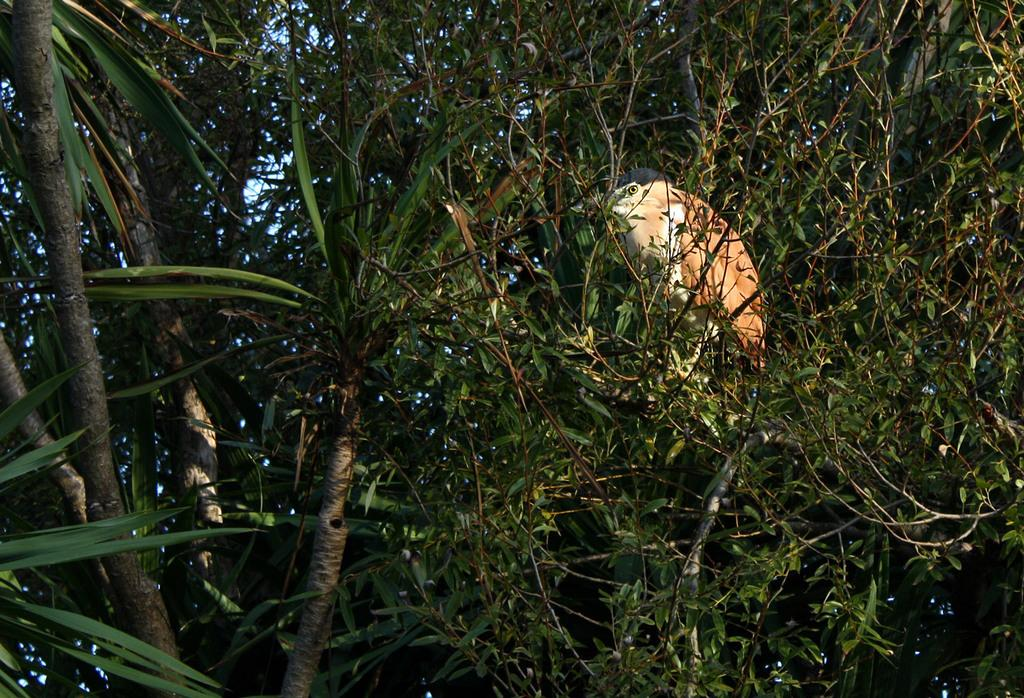What type of vegetation can be seen in the image? There are trees in the image. Is there any wildlife visible in the image? Yes, there is a bird on one of the trees. What brand of toothpaste is being advertised on the tree in the image? There is no toothpaste or advertisement present in the image; it features trees and a bird. 